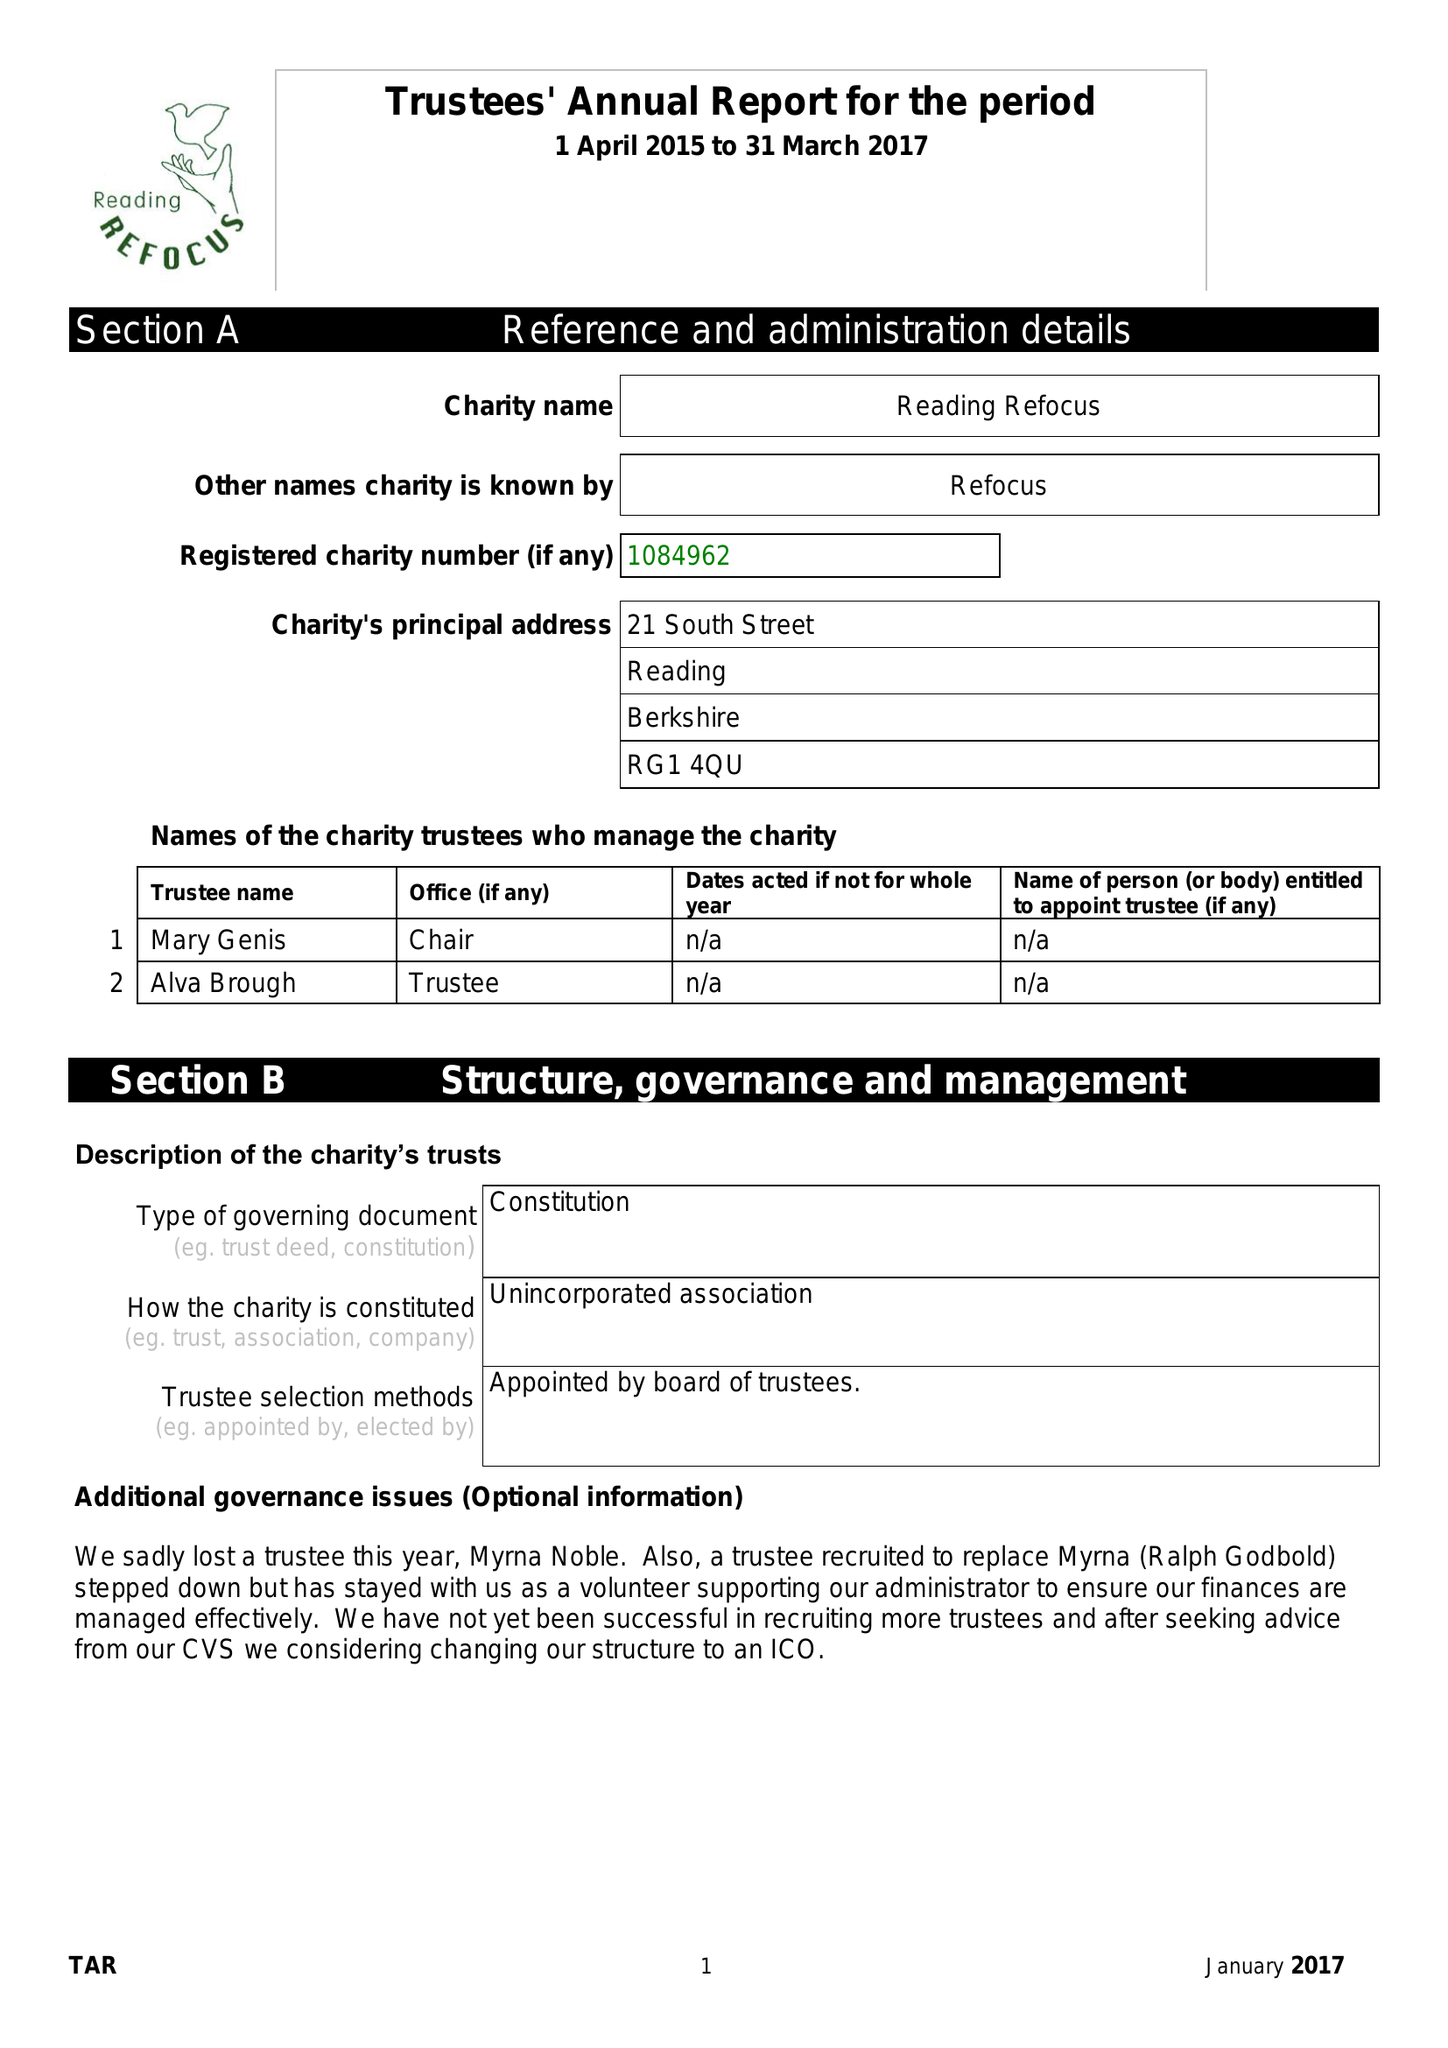What is the value for the address__street_line?
Answer the question using a single word or phrase. 21 SOUTH STREET 